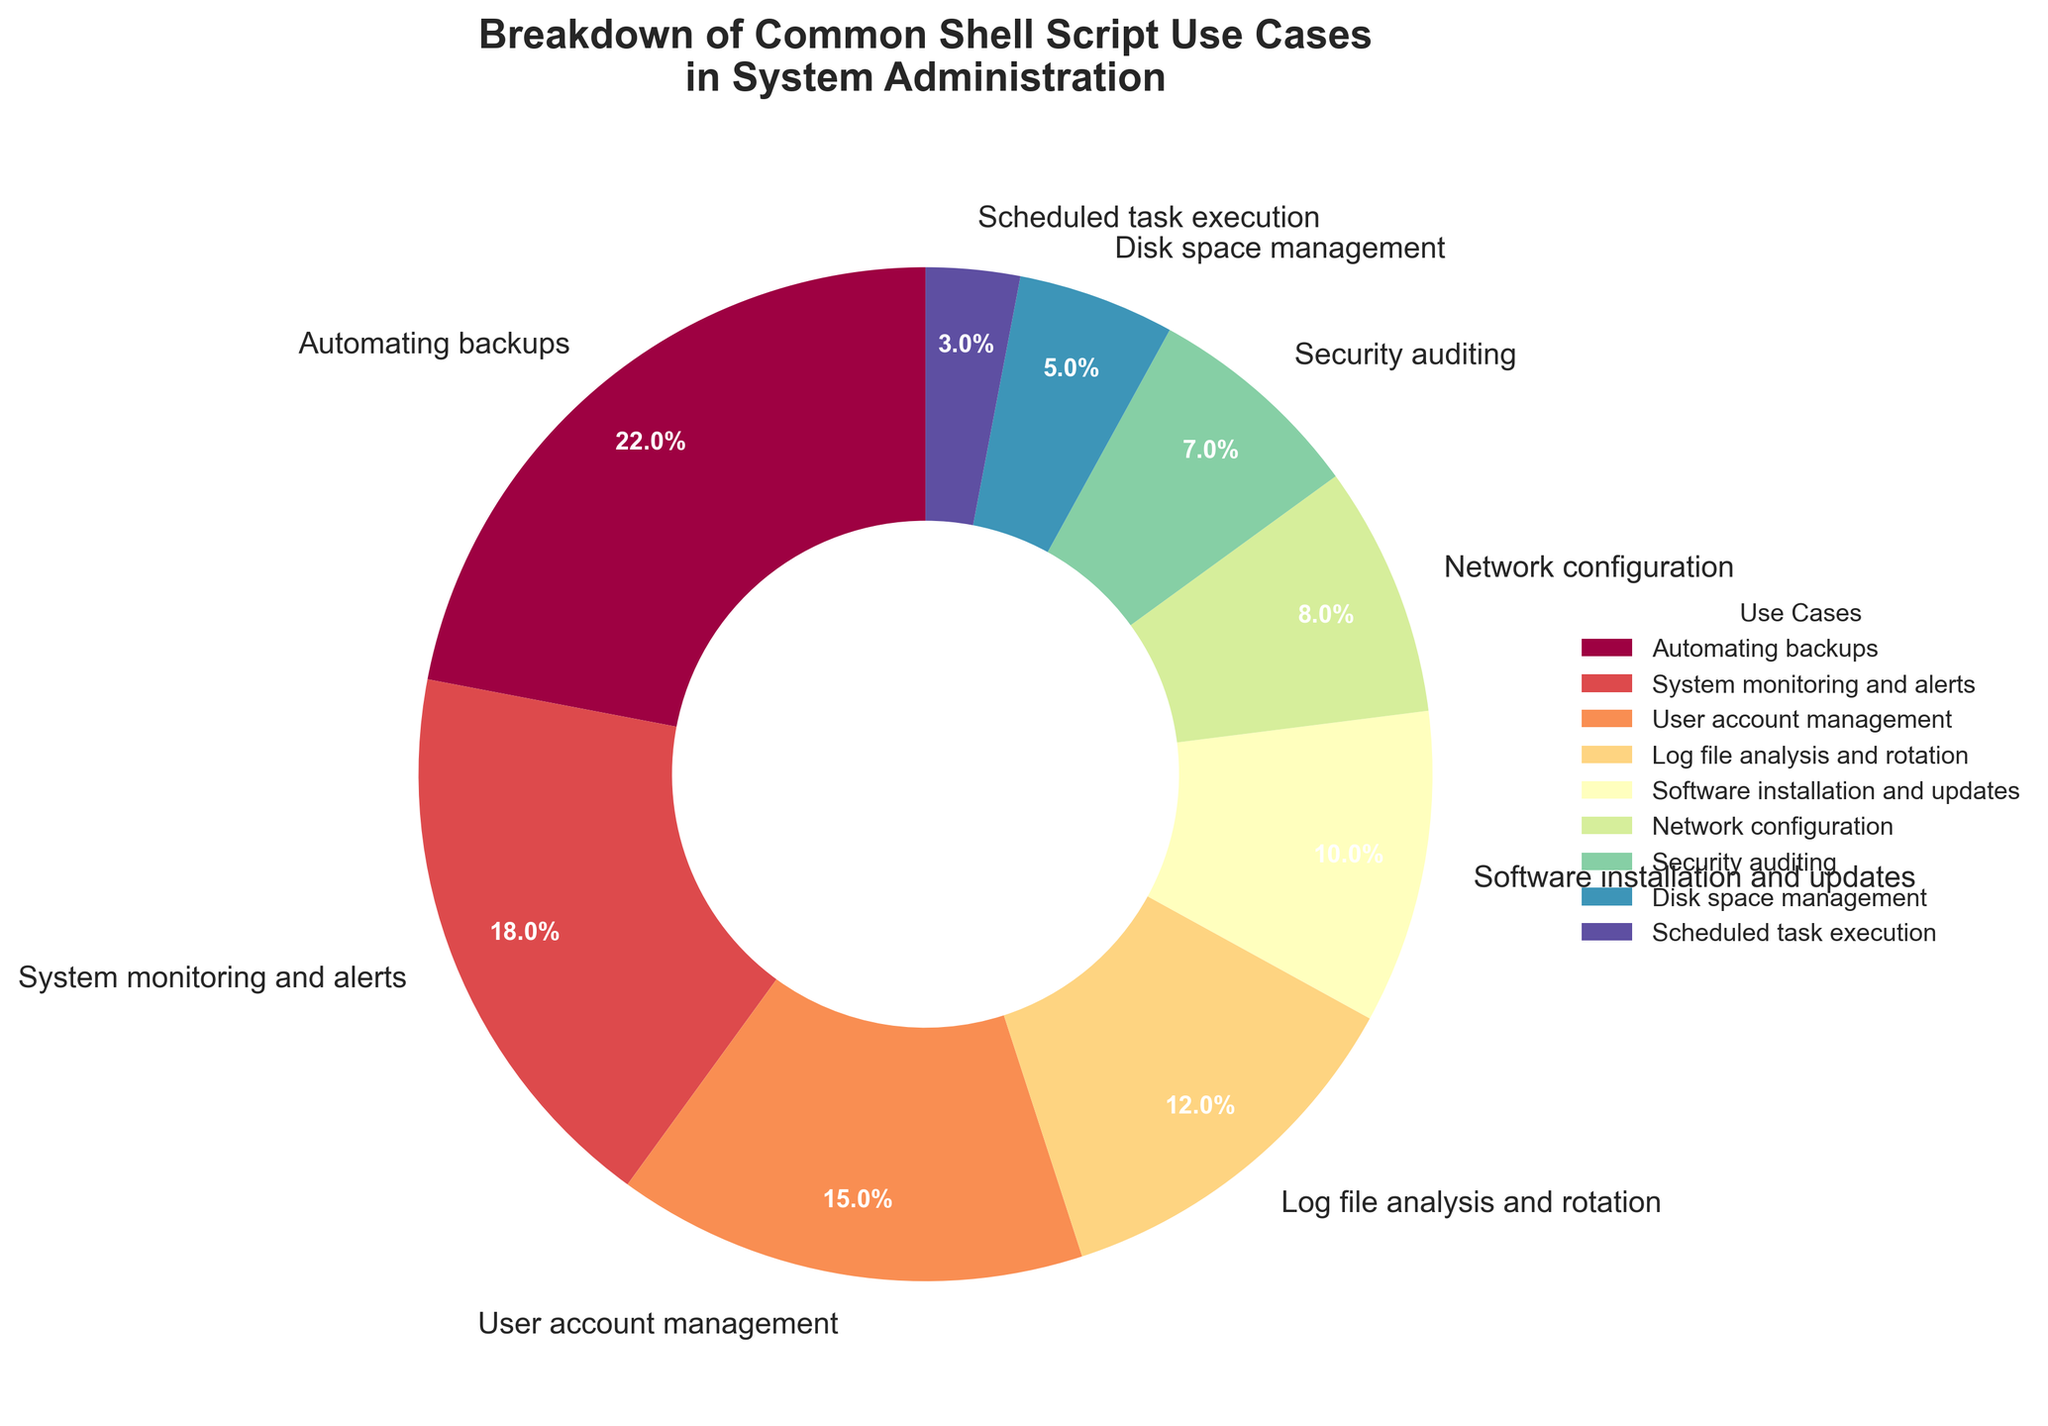What percentage of use cases in the pie chart are related to security (including Security auditing and System monitoring and alerts)? Sum the percentages of "Security auditing" and "System monitoring and alerts": 7% + 18% = 25%
Answer: 25% Which use case has the lowest percentage among all the categories? Look at the slices of the pie chart and identify the smallest one. "Scheduled task execution" has the smallest size at 3%.
Answer: Scheduled task execution What is the combined percentage of use cases related to file management (including Automating backups and Log file analysis and rotation)? Sum the percentages of "Automating backups" and "Log file analysis and rotation": 22% + 12% = 34%
Answer: 34% Which use case has a larger percentage: Network configuration or Disk space management? Compare the percentages of "Network configuration" (8%) and "Disk space management" (5%). Network configuration is larger.
Answer: Network configuration How much more is the percentage of User account management than Software installation and updates? Subtract the percentage of "Software installation and updates" from "User account management": 15% - 10% = 5%
Answer: 5% List the use cases that share the same color and describe the color. None of the use cases share the same color according to the pie chart's design where each segment has a unique color.
Answer: None What is the total percentage represented by Automating backups, System monitoring and alerts, and User account management combined? Sum the percentages: 22% (Automating backups) + 18% (System monitoring and alerts) + 15% (User account management) = 55%
Answer: 55% Among these use cases, which has the second-highest percentage after Automating backups? Identify the use case with the second-largest slice after Automating backups (22%). "System monitoring and alerts" is the second-highest at 18%.
Answer: System monitoring and alerts What is the average percentage of the use cases that are less than 10%? Identify the use cases under 10%: Software installation and updates (10%), Network configuration (8%), Security auditing (7%), Disk space management (5%), Scheduled task execution (3%). Calculate the average: (10% + 8% + 7% + 5% + 3%) / 5 = 33% / 5 = 6.6%
Answer: 6.6% Which two use cases combined make up approximately the same percentage as Automating backups? Find two use cases whose combined percentages approximate 22%. "System monitoring and alerts" (18%) and "Disk space management" (5%) combined make 23%, which is closest to 22%.
Answer: System monitoring and alerts and Disk space management 